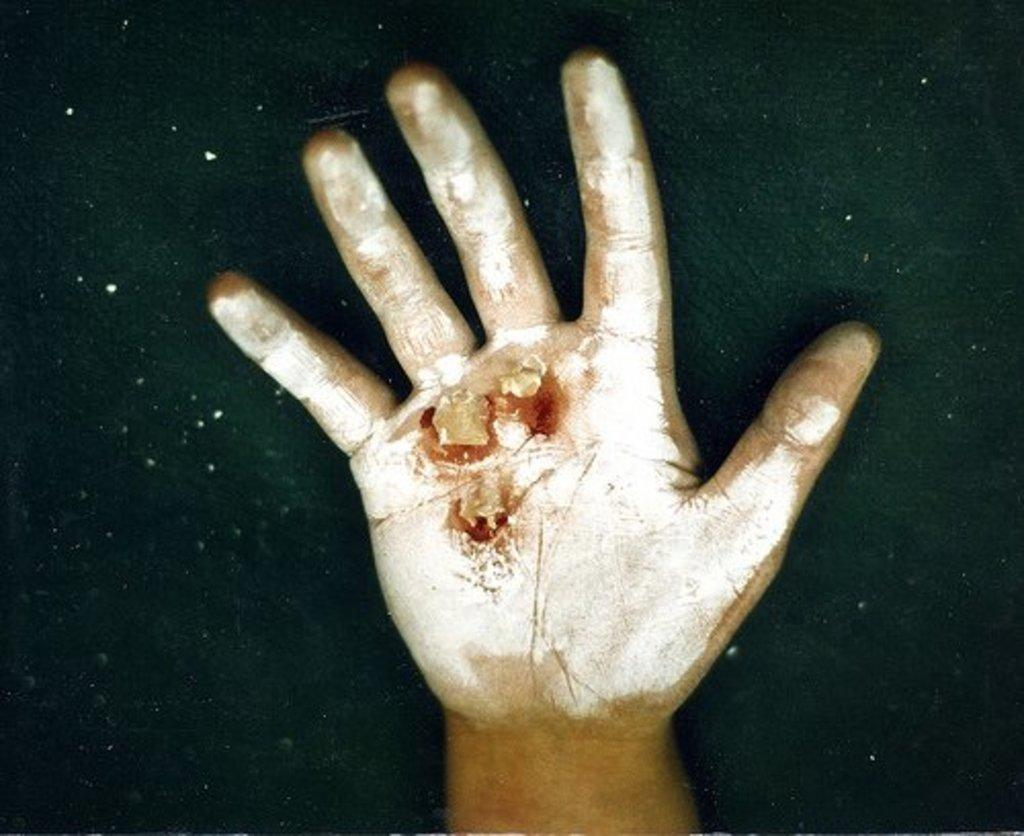What part of a person's body is visible in the image? There is a person's hand visible in the image. Can you describe the condition of the hand? The hand has an injury. What color is the background of the image? The background of the image is black. How many babies are present on the roof in the image? There are no babies or roof present in the image; it only features a person's hand with an injury against a black background. 